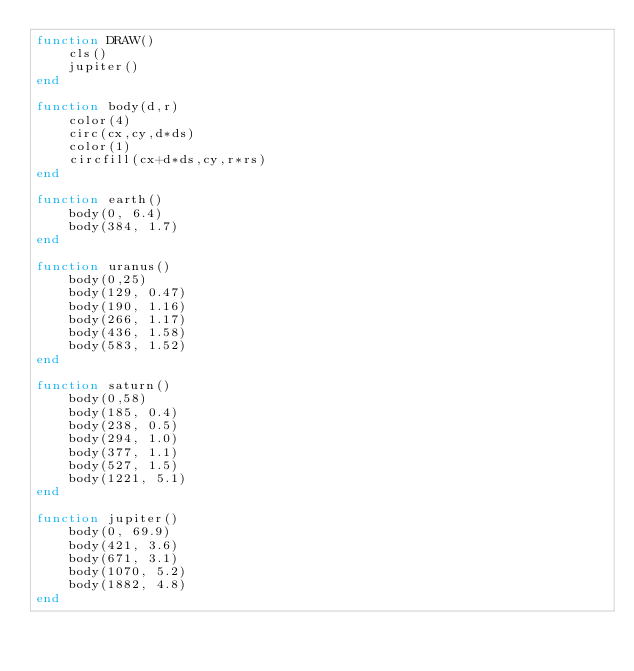Convert code to text. <code><loc_0><loc_0><loc_500><loc_500><_Lua_>function DRAW()
	cls()
	jupiter()
end

function body(d,r)
	color(4)
	circ(cx,cy,d*ds)
	color(1)
	circfill(cx+d*ds,cy,r*rs)
end

function earth()
	body(0, 6.4)
	body(384, 1.7)
end

function uranus()
	body(0,25)
	body(129, 0.47)
	body(190, 1.16)
	body(266, 1.17)
	body(436, 1.58)
	body(583, 1.52)
end

function saturn()
	body(0,58)
	body(185, 0.4)
	body(238, 0.5)
	body(294, 1.0)
	body(377, 1.1)
	body(527, 1.5)
	body(1221, 5.1)
end

function jupiter()
	body(0, 69.9)
	body(421, 3.6)
	body(671, 3.1)
	body(1070, 5.2)
	body(1882, 4.8)
end</code> 